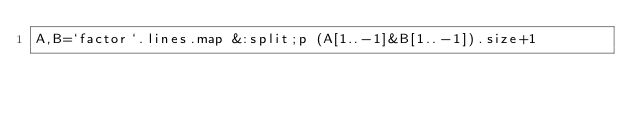Convert code to text. <code><loc_0><loc_0><loc_500><loc_500><_Ruby_>A,B=`factor`.lines.map &:split;p (A[1..-1]&B[1..-1]).size+1</code> 